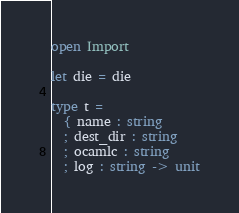Convert code to text. <code><loc_0><loc_0><loc_500><loc_500><_OCaml_>open Import

let die = die

type t =
  { name : string
  ; dest_dir : string
  ; ocamlc : string
  ; log : string -> unit</code> 